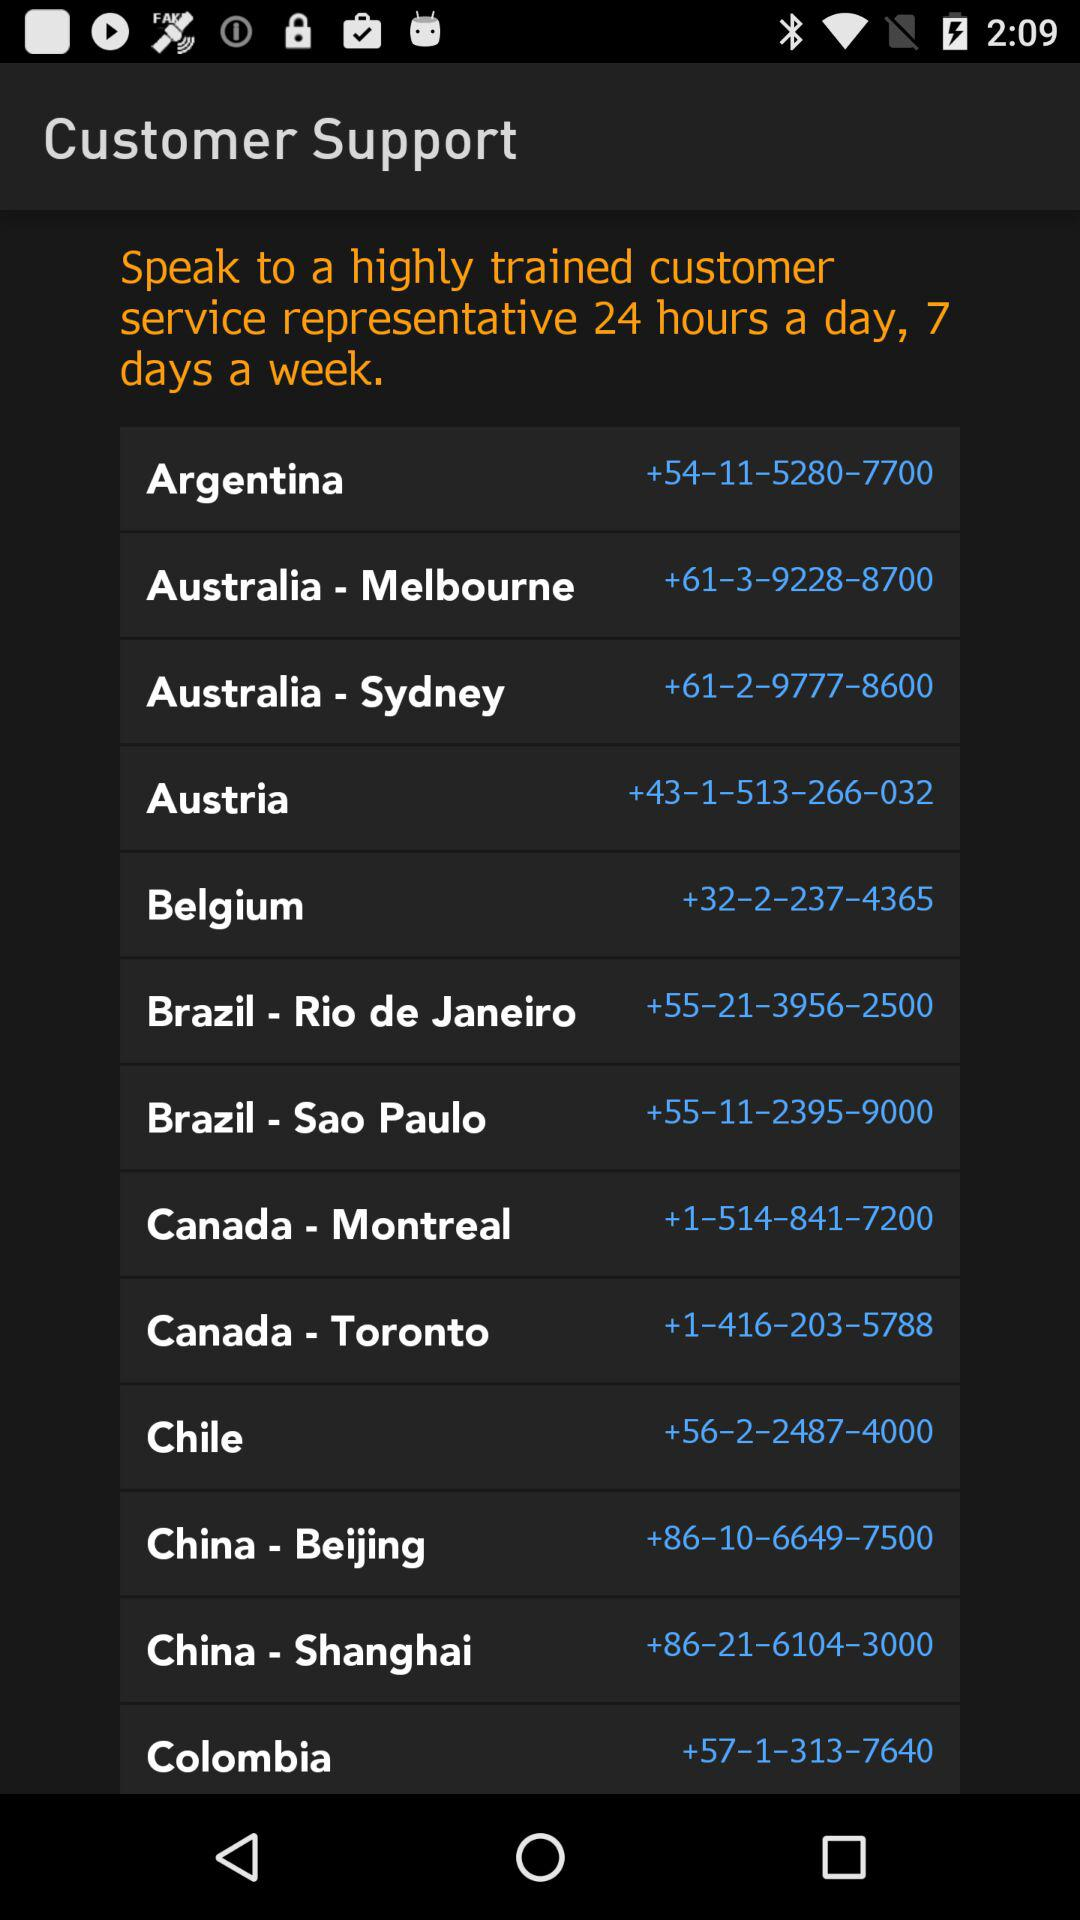What is the contact number for Colombia? The contact number for Colombia is +57-1-313-7640. 